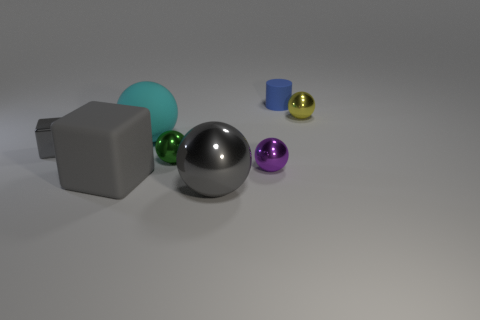Add 2 large yellow balls. How many objects exist? 10 Subtract all tiny green metal balls. How many balls are left? 4 Subtract 0 red cubes. How many objects are left? 8 Subtract all cubes. How many objects are left? 6 Subtract 1 balls. How many balls are left? 4 Subtract all blue balls. Subtract all yellow cylinders. How many balls are left? 5 Subtract all blue cubes. How many purple cylinders are left? 0 Subtract all tiny blue metal cylinders. Subtract all small metallic objects. How many objects are left? 4 Add 5 purple balls. How many purple balls are left? 6 Add 3 yellow objects. How many yellow objects exist? 4 